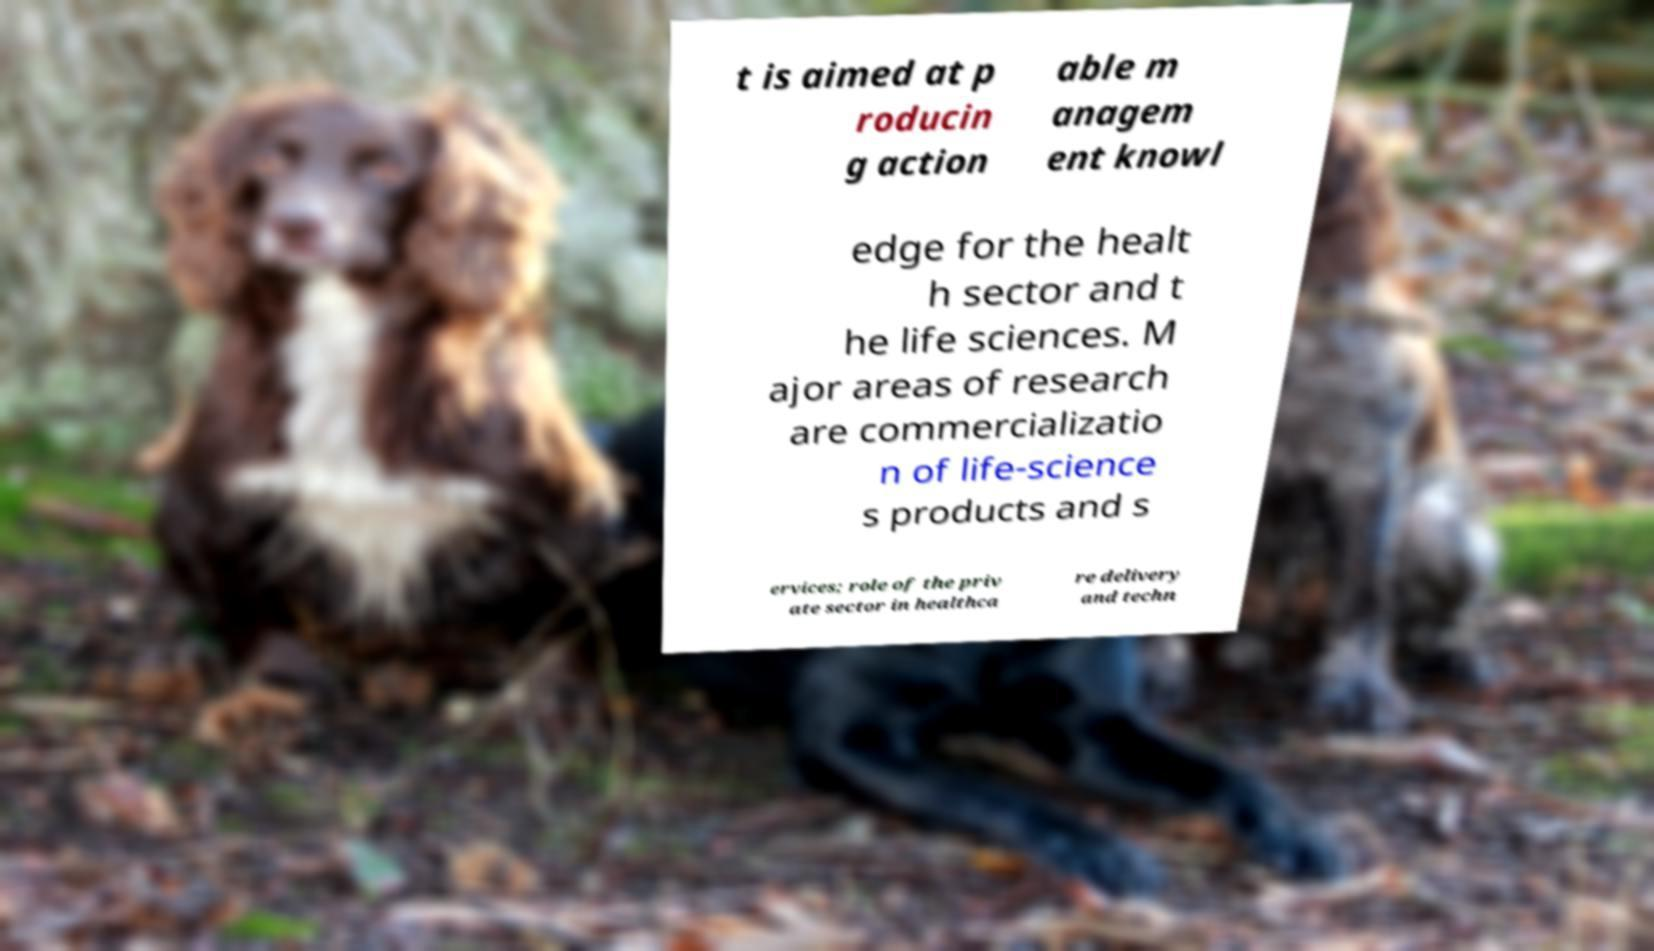Please read and relay the text visible in this image. What does it say? t is aimed at p roducin g action able m anagem ent knowl edge for the healt h sector and t he life sciences. M ajor areas of research are commercializatio n of life-science s products and s ervices; role of the priv ate sector in healthca re delivery and techn 